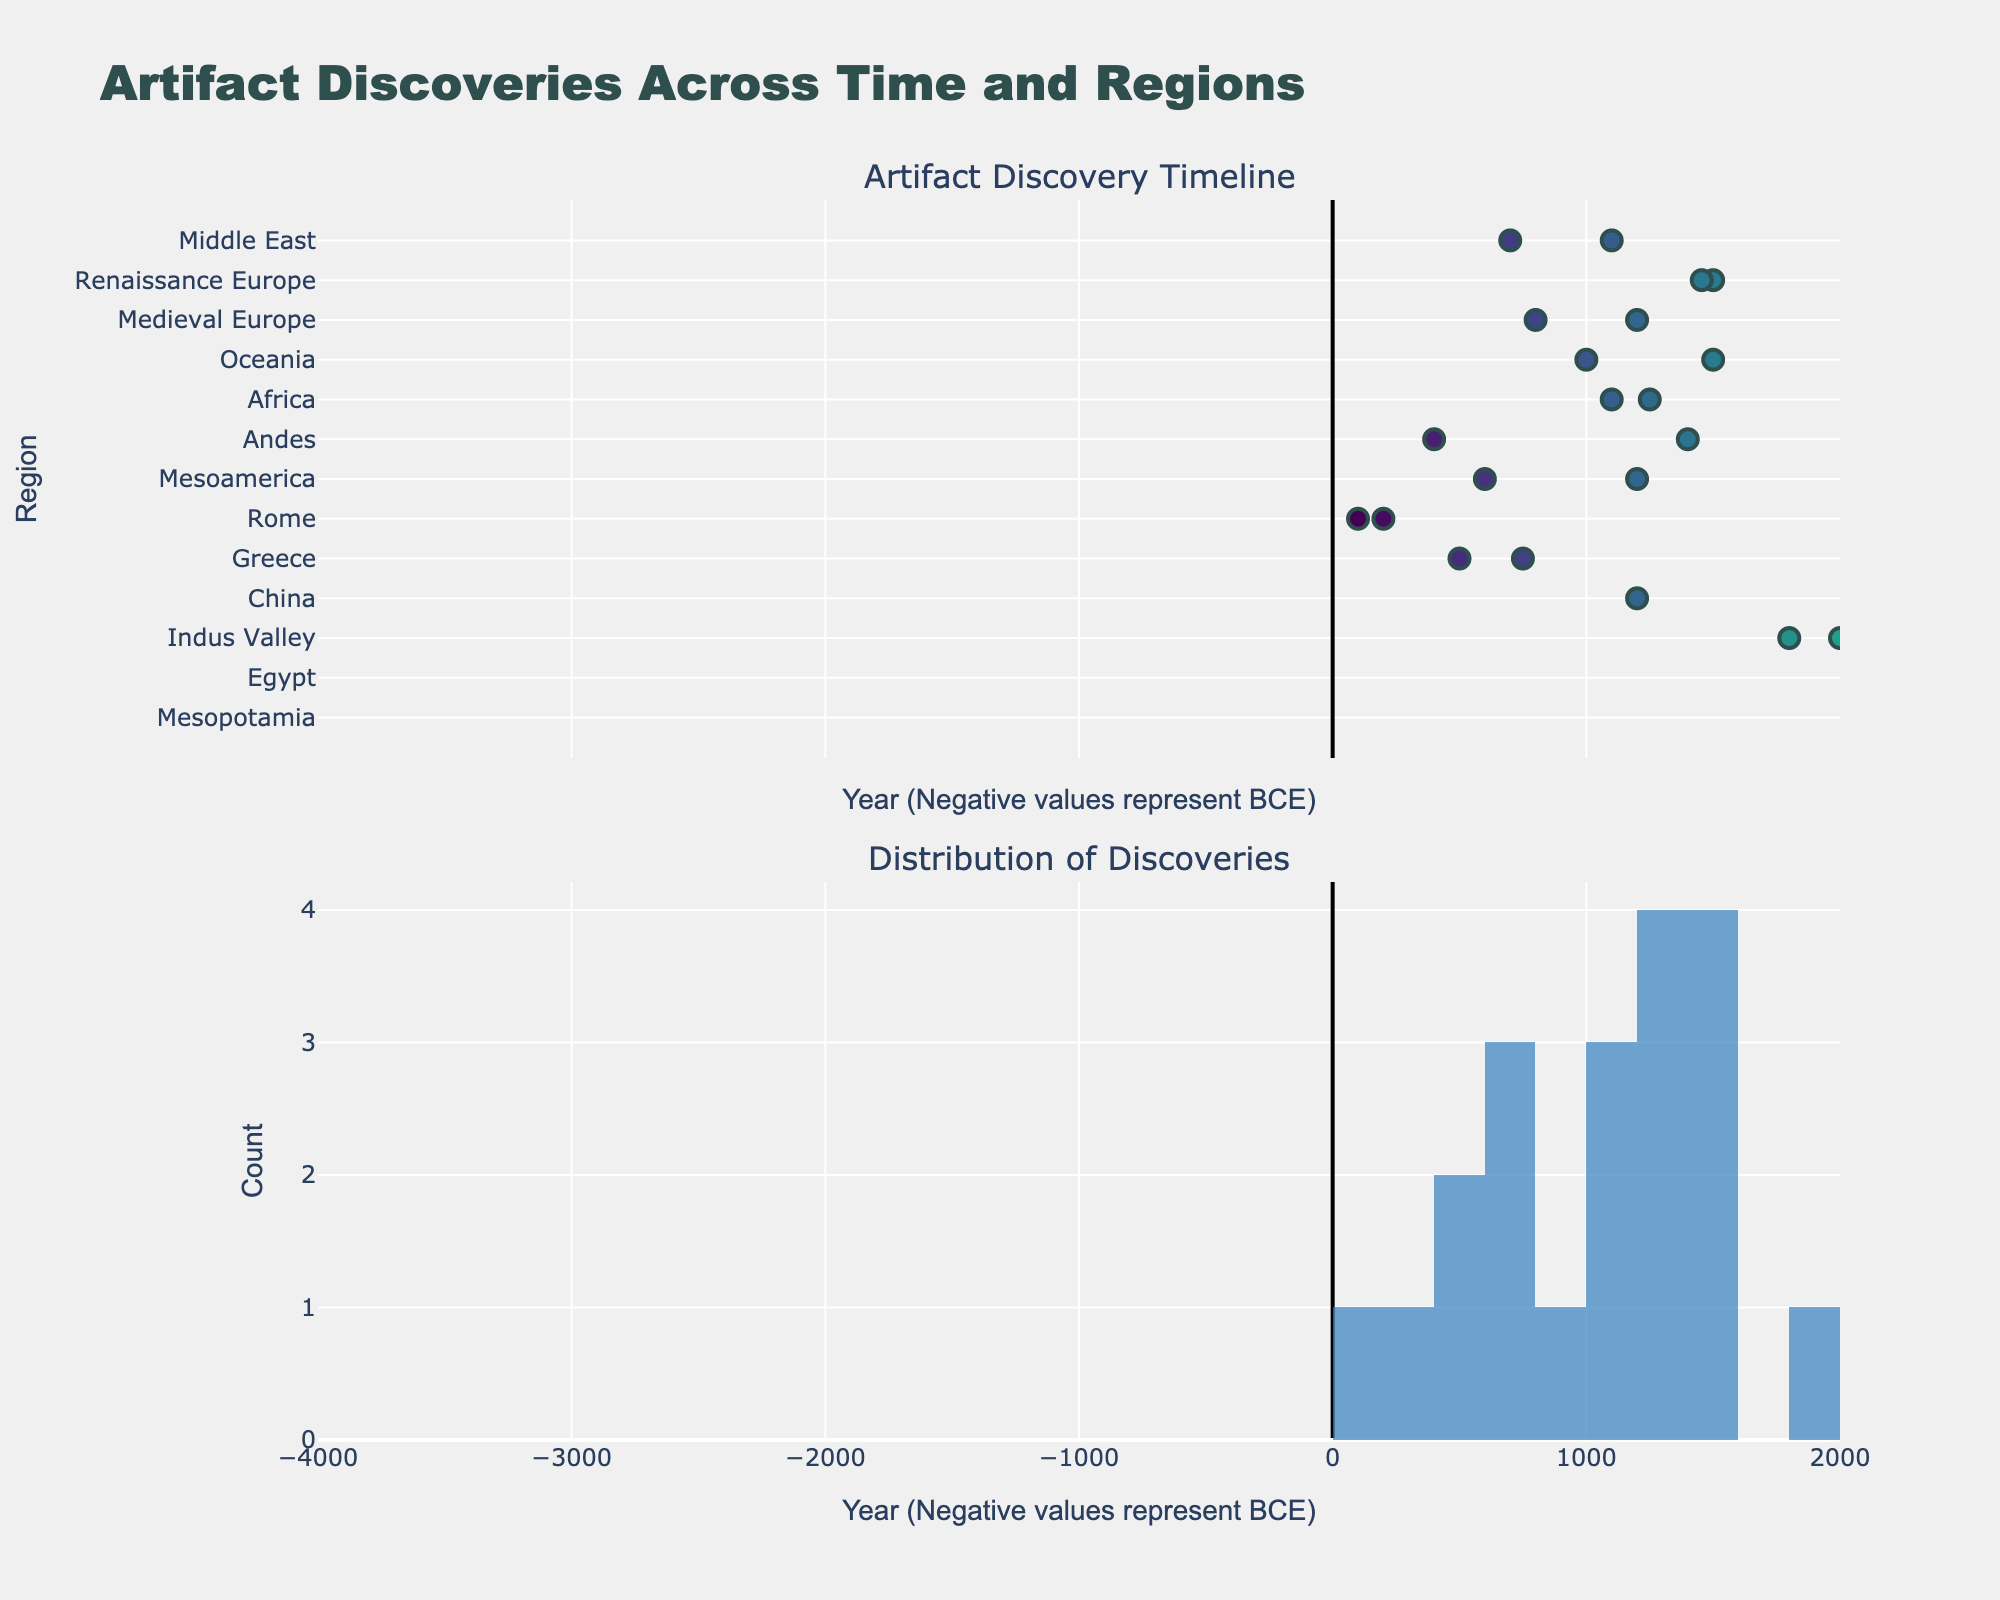What region has the earliest artifact discovery date? The scatter plot shows various markers on a timeline, with regions on the y-axis and years on the x-axis. The earliest discovery date on the plot is for Mesopotamia around 3500 BCE.
Answer: Mesopotamia During which period is there the highest concentration of artifact discoveries? Looking at the histogram, the bins with the highest bars indicate periods with the most discoveries. The highest concentration of discoveries is around 1200 CE.
Answer: 1200 CE How many discoveries are recorded in the Medieval period (500 CE to 1500 CE)? To find this, count the discoveries between 500 CE and 1500 CE on the scatter plot. Regions include Medieval Europe and Renaissance Europe. The data points are 12 in this range.
Answer: 12 Which artifact type is associated with the 200 CE discovery in Rome? Check the hover information of the marker at 200 CE within the Rome region on the scatter plot. The artifact type listed is Latin Manuscripts.
Answer: Latin Manuscripts Compare the number of artifacts discovered in BCE versus CE. Which period has more discoveries? Count the markers in the BCE period (years shown as negative) and compare with those in the CE period (positive years). There are 7 artifacts in BCE and 19 in CE.
Answer: CE What's the difference between the greatest and least number of discoveries within a single bin in the histogram? Identify the highest bin count and the lowest bin count in the histogram. The highest bin shows 6 discoveries and the lowest bin shows 1 discovery. The difference is 6 - 1 = 5.
Answer: 5 